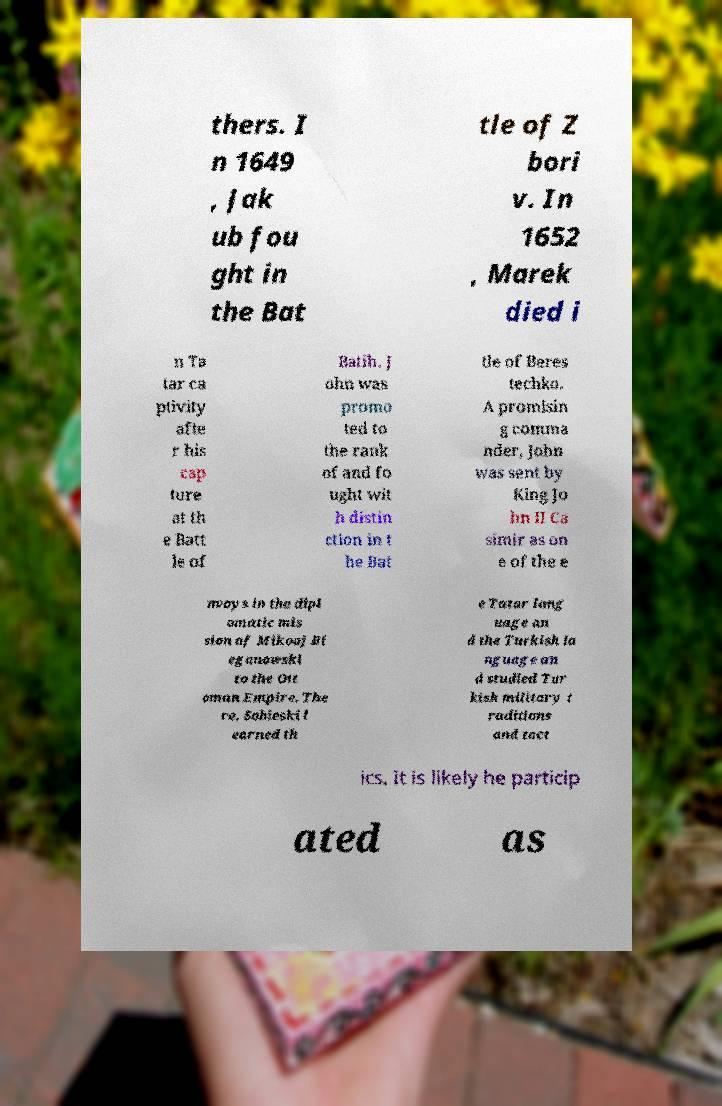What messages or text are displayed in this image? I need them in a readable, typed format. thers. I n 1649 , Jak ub fou ght in the Bat tle of Z bori v. In 1652 , Marek died i n Ta tar ca ptivity afte r his cap ture at th e Batt le of Batih. J ohn was promo ted to the rank of and fo ught wit h distin ction in t he Bat tle of Beres techko. A promisin g comma nder, John was sent by King Jo hn II Ca simir as on e of the e nvoys in the dipl omatic mis sion of Mikoaj Bi eganowski to the Ott oman Empire. The re, Sobieski l earned th e Tatar lang uage an d the Turkish la nguage an d studied Tur kish military t raditions and tact ics. It is likely he particip ated as 